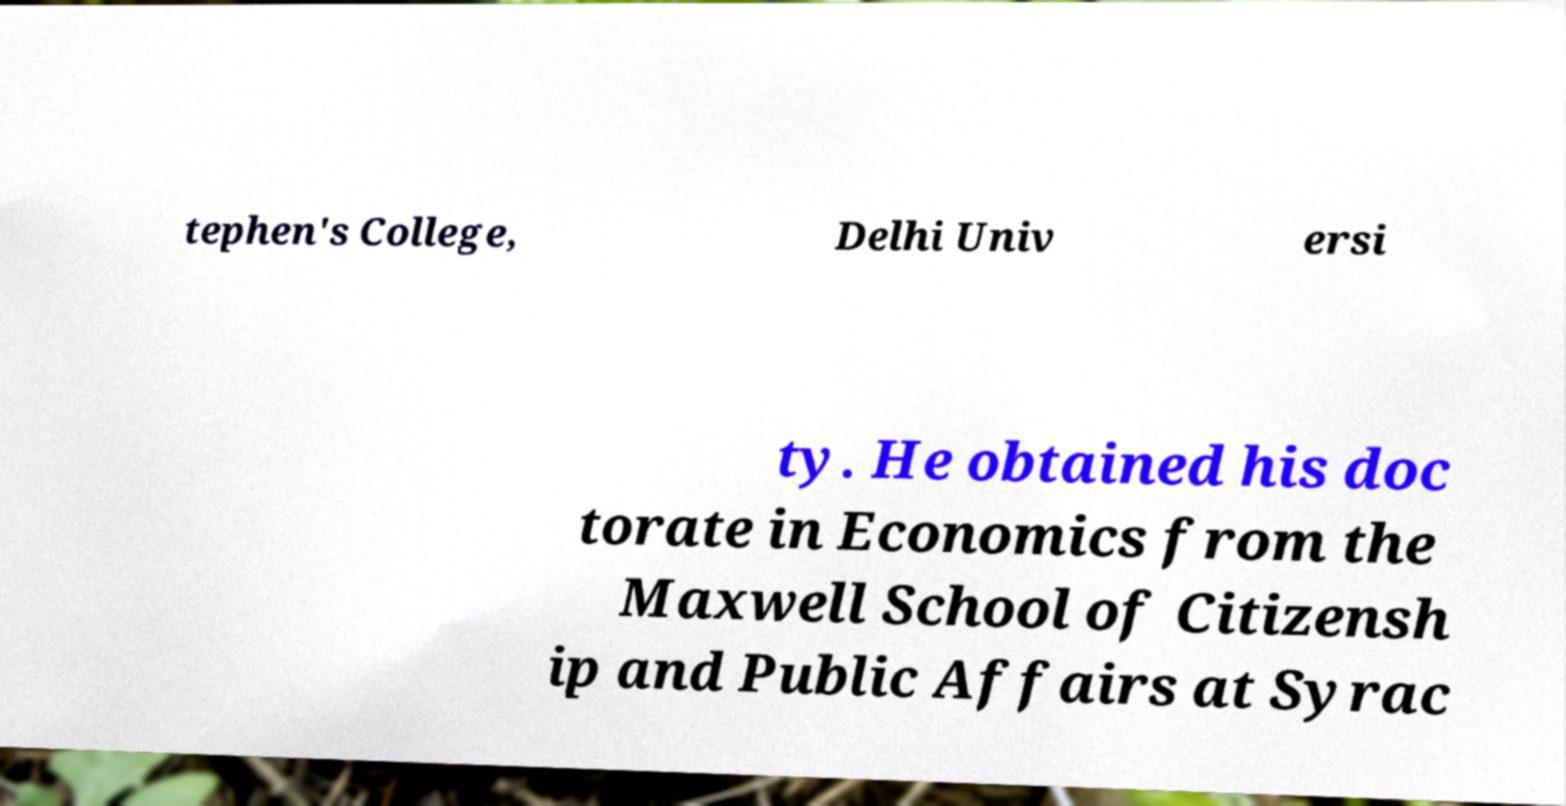Can you accurately transcribe the text from the provided image for me? tephen's College, Delhi Univ ersi ty. He obtained his doc torate in Economics from the Maxwell School of Citizensh ip and Public Affairs at Syrac 